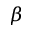<formula> <loc_0><loc_0><loc_500><loc_500>\beta</formula> 